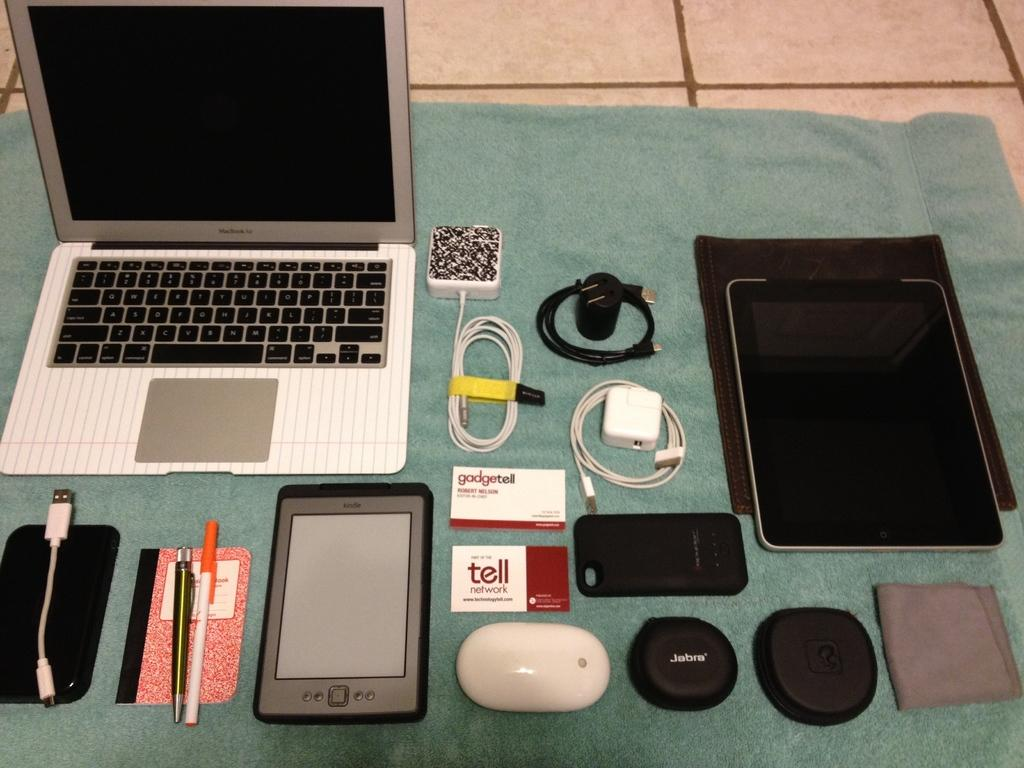<image>
Provide a brief description of the given image. A table hols a lot of items and a card says gadgetell. 